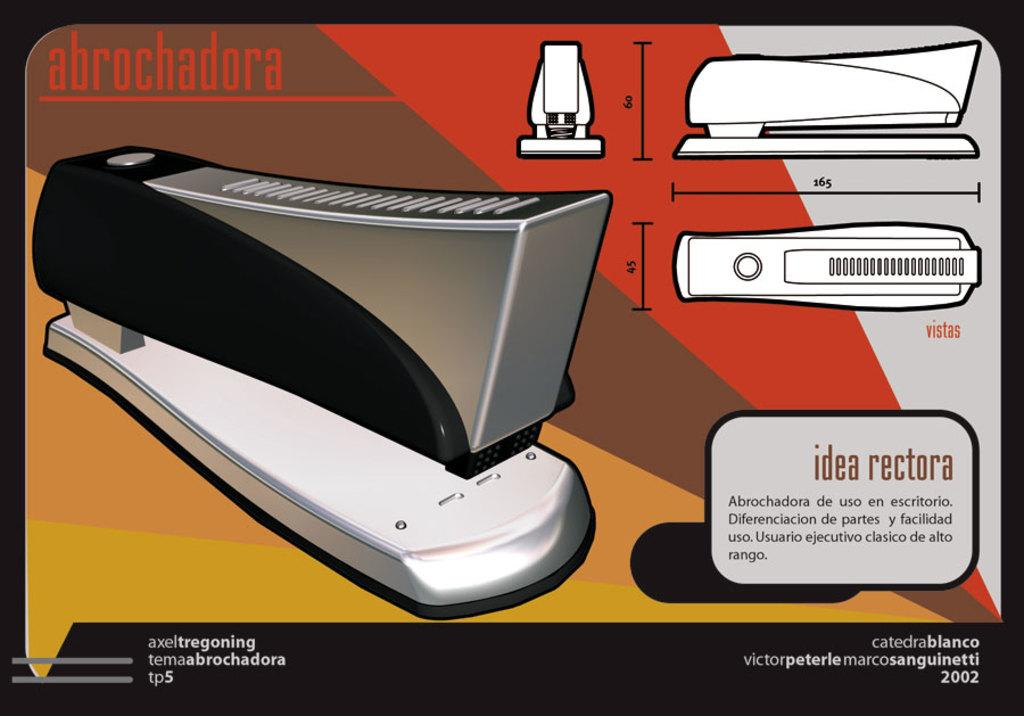<image>
Share a concise interpretation of the image provided. An image showing the specifications of a stapler with the word abrochadora in the upper left. 